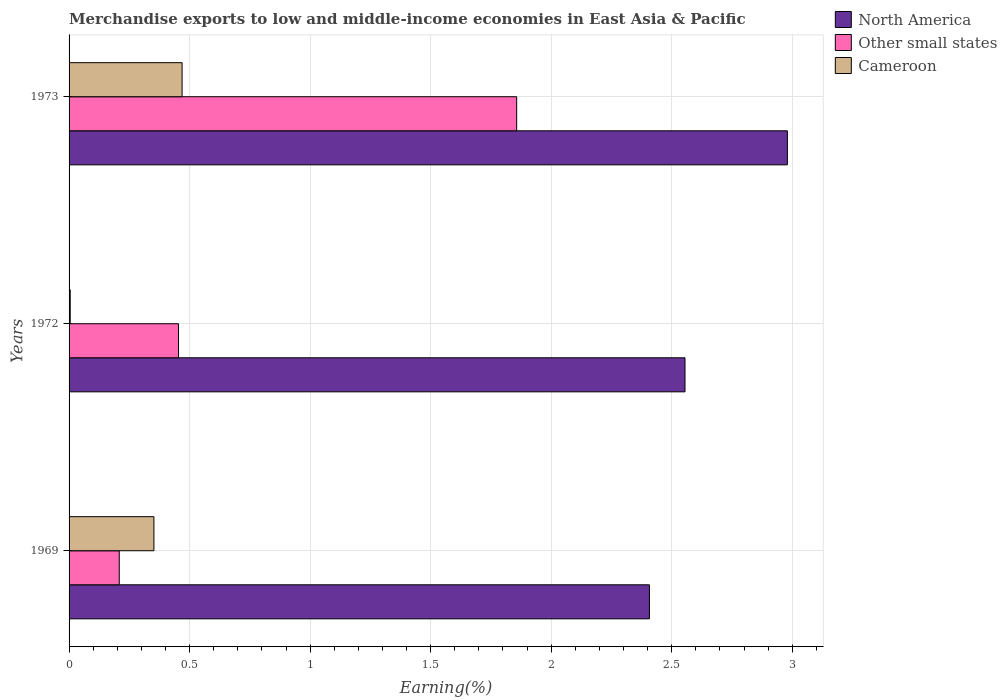How many different coloured bars are there?
Make the answer very short. 3. How many groups of bars are there?
Your answer should be very brief. 3. Are the number of bars per tick equal to the number of legend labels?
Give a very brief answer. Yes. Are the number of bars on each tick of the Y-axis equal?
Offer a very short reply. Yes. What is the label of the 3rd group of bars from the top?
Your answer should be compact. 1969. What is the percentage of amount earned from merchandise exports in Other small states in 1973?
Make the answer very short. 1.86. Across all years, what is the maximum percentage of amount earned from merchandise exports in North America?
Offer a very short reply. 2.98. Across all years, what is the minimum percentage of amount earned from merchandise exports in Cameroon?
Your answer should be very brief. 0. What is the total percentage of amount earned from merchandise exports in North America in the graph?
Your response must be concise. 7.94. What is the difference between the percentage of amount earned from merchandise exports in North America in 1972 and that in 1973?
Provide a short and direct response. -0.42. What is the difference between the percentage of amount earned from merchandise exports in North America in 1969 and the percentage of amount earned from merchandise exports in Cameroon in 1973?
Give a very brief answer. 1.94. What is the average percentage of amount earned from merchandise exports in North America per year?
Ensure brevity in your answer.  2.65. In the year 1972, what is the difference between the percentage of amount earned from merchandise exports in Cameroon and percentage of amount earned from merchandise exports in North America?
Give a very brief answer. -2.55. In how many years, is the percentage of amount earned from merchandise exports in Other small states greater than 1.8 %?
Provide a succinct answer. 1. What is the ratio of the percentage of amount earned from merchandise exports in Other small states in 1969 to that in 1973?
Your answer should be very brief. 0.11. Is the percentage of amount earned from merchandise exports in North America in 1969 less than that in 1973?
Make the answer very short. Yes. What is the difference between the highest and the second highest percentage of amount earned from merchandise exports in North America?
Keep it short and to the point. 0.42. What is the difference between the highest and the lowest percentage of amount earned from merchandise exports in North America?
Your answer should be compact. 0.57. In how many years, is the percentage of amount earned from merchandise exports in Other small states greater than the average percentage of amount earned from merchandise exports in Other small states taken over all years?
Offer a terse response. 1. What does the 3rd bar from the top in 1973 represents?
Provide a short and direct response. North America. What does the 3rd bar from the bottom in 1973 represents?
Offer a terse response. Cameroon. How many bars are there?
Provide a short and direct response. 9. What is the difference between two consecutive major ticks on the X-axis?
Provide a short and direct response. 0.5. Does the graph contain grids?
Provide a short and direct response. Yes. How many legend labels are there?
Make the answer very short. 3. What is the title of the graph?
Provide a short and direct response. Merchandise exports to low and middle-income economies in East Asia & Pacific. Does "Comoros" appear as one of the legend labels in the graph?
Offer a terse response. No. What is the label or title of the X-axis?
Provide a short and direct response. Earning(%). What is the Earning(%) in North America in 1969?
Your answer should be compact. 2.41. What is the Earning(%) in Other small states in 1969?
Make the answer very short. 0.21. What is the Earning(%) in Cameroon in 1969?
Your response must be concise. 0.35. What is the Earning(%) in North America in 1972?
Offer a terse response. 2.56. What is the Earning(%) of Other small states in 1972?
Make the answer very short. 0.45. What is the Earning(%) of Cameroon in 1972?
Offer a very short reply. 0. What is the Earning(%) of North America in 1973?
Your answer should be very brief. 2.98. What is the Earning(%) in Other small states in 1973?
Give a very brief answer. 1.86. What is the Earning(%) in Cameroon in 1973?
Offer a terse response. 0.47. Across all years, what is the maximum Earning(%) of North America?
Provide a short and direct response. 2.98. Across all years, what is the maximum Earning(%) in Other small states?
Your answer should be very brief. 1.86. Across all years, what is the maximum Earning(%) in Cameroon?
Ensure brevity in your answer.  0.47. Across all years, what is the minimum Earning(%) in North America?
Provide a succinct answer. 2.41. Across all years, what is the minimum Earning(%) in Other small states?
Your response must be concise. 0.21. Across all years, what is the minimum Earning(%) in Cameroon?
Provide a short and direct response. 0. What is the total Earning(%) of North America in the graph?
Your response must be concise. 7.94. What is the total Earning(%) of Other small states in the graph?
Offer a very short reply. 2.52. What is the total Earning(%) in Cameroon in the graph?
Make the answer very short. 0.83. What is the difference between the Earning(%) of North America in 1969 and that in 1972?
Your response must be concise. -0.15. What is the difference between the Earning(%) in Other small states in 1969 and that in 1972?
Make the answer very short. -0.25. What is the difference between the Earning(%) of Cameroon in 1969 and that in 1972?
Your response must be concise. 0.35. What is the difference between the Earning(%) of North America in 1969 and that in 1973?
Provide a succinct answer. -0.57. What is the difference between the Earning(%) in Other small states in 1969 and that in 1973?
Give a very brief answer. -1.65. What is the difference between the Earning(%) in Cameroon in 1969 and that in 1973?
Your answer should be very brief. -0.12. What is the difference between the Earning(%) in North America in 1972 and that in 1973?
Your answer should be compact. -0.42. What is the difference between the Earning(%) in Other small states in 1972 and that in 1973?
Your answer should be compact. -1.4. What is the difference between the Earning(%) of Cameroon in 1972 and that in 1973?
Ensure brevity in your answer.  -0.46. What is the difference between the Earning(%) of North America in 1969 and the Earning(%) of Other small states in 1972?
Make the answer very short. 1.95. What is the difference between the Earning(%) in North America in 1969 and the Earning(%) in Cameroon in 1972?
Provide a short and direct response. 2.4. What is the difference between the Earning(%) in Other small states in 1969 and the Earning(%) in Cameroon in 1972?
Ensure brevity in your answer.  0.2. What is the difference between the Earning(%) of North America in 1969 and the Earning(%) of Other small states in 1973?
Make the answer very short. 0.55. What is the difference between the Earning(%) in North America in 1969 and the Earning(%) in Cameroon in 1973?
Keep it short and to the point. 1.94. What is the difference between the Earning(%) of Other small states in 1969 and the Earning(%) of Cameroon in 1973?
Your answer should be very brief. -0.26. What is the difference between the Earning(%) in North America in 1972 and the Earning(%) in Other small states in 1973?
Your response must be concise. 0.7. What is the difference between the Earning(%) in North America in 1972 and the Earning(%) in Cameroon in 1973?
Offer a terse response. 2.09. What is the difference between the Earning(%) in Other small states in 1972 and the Earning(%) in Cameroon in 1973?
Your answer should be compact. -0.01. What is the average Earning(%) of North America per year?
Make the answer very short. 2.65. What is the average Earning(%) in Other small states per year?
Provide a succinct answer. 0.84. What is the average Earning(%) in Cameroon per year?
Your answer should be very brief. 0.28. In the year 1969, what is the difference between the Earning(%) in North America and Earning(%) in Other small states?
Ensure brevity in your answer.  2.2. In the year 1969, what is the difference between the Earning(%) of North America and Earning(%) of Cameroon?
Offer a terse response. 2.06. In the year 1969, what is the difference between the Earning(%) of Other small states and Earning(%) of Cameroon?
Offer a very short reply. -0.14. In the year 1972, what is the difference between the Earning(%) of North America and Earning(%) of Other small states?
Your response must be concise. 2.1. In the year 1972, what is the difference between the Earning(%) of North America and Earning(%) of Cameroon?
Offer a terse response. 2.55. In the year 1972, what is the difference between the Earning(%) in Other small states and Earning(%) in Cameroon?
Make the answer very short. 0.45. In the year 1973, what is the difference between the Earning(%) in North America and Earning(%) in Other small states?
Keep it short and to the point. 1.12. In the year 1973, what is the difference between the Earning(%) in North America and Earning(%) in Cameroon?
Your answer should be very brief. 2.51. In the year 1973, what is the difference between the Earning(%) of Other small states and Earning(%) of Cameroon?
Your answer should be compact. 1.39. What is the ratio of the Earning(%) of North America in 1969 to that in 1972?
Provide a short and direct response. 0.94. What is the ratio of the Earning(%) in Other small states in 1969 to that in 1972?
Your answer should be compact. 0.46. What is the ratio of the Earning(%) in Cameroon in 1969 to that in 1972?
Your response must be concise. 73.52. What is the ratio of the Earning(%) in North America in 1969 to that in 1973?
Offer a very short reply. 0.81. What is the ratio of the Earning(%) in Other small states in 1969 to that in 1973?
Provide a short and direct response. 0.11. What is the ratio of the Earning(%) in Cameroon in 1969 to that in 1973?
Offer a very short reply. 0.75. What is the ratio of the Earning(%) in North America in 1972 to that in 1973?
Your answer should be very brief. 0.86. What is the ratio of the Earning(%) in Other small states in 1972 to that in 1973?
Your answer should be very brief. 0.24. What is the ratio of the Earning(%) in Cameroon in 1972 to that in 1973?
Your answer should be very brief. 0.01. What is the difference between the highest and the second highest Earning(%) of North America?
Keep it short and to the point. 0.42. What is the difference between the highest and the second highest Earning(%) of Other small states?
Provide a short and direct response. 1.4. What is the difference between the highest and the second highest Earning(%) in Cameroon?
Your answer should be very brief. 0.12. What is the difference between the highest and the lowest Earning(%) of North America?
Your response must be concise. 0.57. What is the difference between the highest and the lowest Earning(%) of Other small states?
Offer a terse response. 1.65. What is the difference between the highest and the lowest Earning(%) in Cameroon?
Your response must be concise. 0.46. 